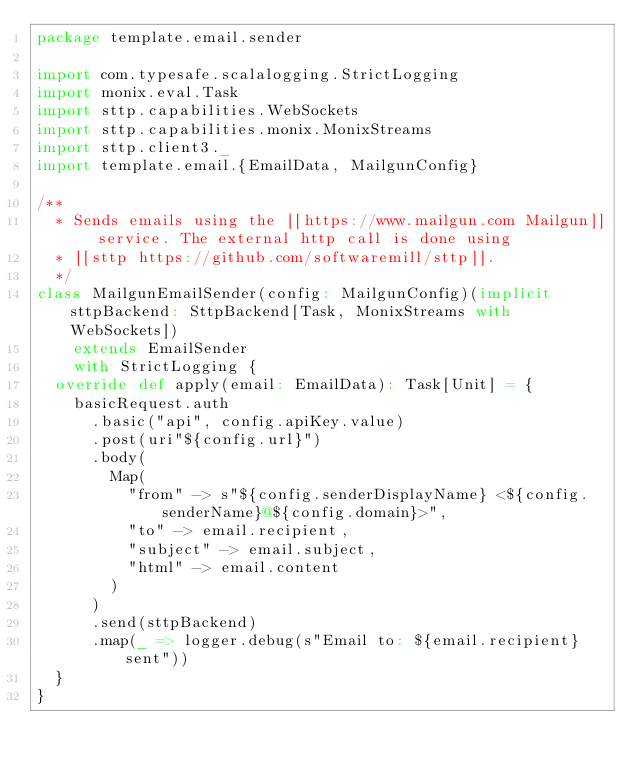<code> <loc_0><loc_0><loc_500><loc_500><_Scala_>package template.email.sender

import com.typesafe.scalalogging.StrictLogging
import monix.eval.Task
import sttp.capabilities.WebSockets
import sttp.capabilities.monix.MonixStreams
import sttp.client3._
import template.email.{EmailData, MailgunConfig}

/**
  * Sends emails using the [[https://www.mailgun.com Mailgun]] service. The external http call is done using
  * [[sttp https://github.com/softwaremill/sttp]].
  */
class MailgunEmailSender(config: MailgunConfig)(implicit sttpBackend: SttpBackend[Task, MonixStreams with WebSockets])
    extends EmailSender
    with StrictLogging {
  override def apply(email: EmailData): Task[Unit] = {
    basicRequest.auth
      .basic("api", config.apiKey.value)
      .post(uri"${config.url}")
      .body(
        Map(
          "from" -> s"${config.senderDisplayName} <${config.senderName}@${config.domain}>",
          "to" -> email.recipient,
          "subject" -> email.subject,
          "html" -> email.content
        )
      )
      .send(sttpBackend)
      .map(_ => logger.debug(s"Email to: ${email.recipient} sent"))
  }
}
</code> 